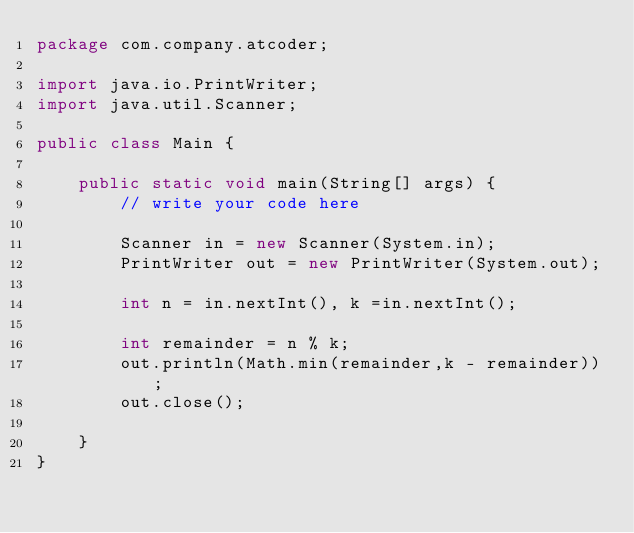Convert code to text. <code><loc_0><loc_0><loc_500><loc_500><_Java_>package com.company.atcoder;

import java.io.PrintWriter;
import java.util.Scanner;

public class Main {

    public static void main(String[] args) {
        // write your code here

        Scanner in = new Scanner(System.in);
        PrintWriter out = new PrintWriter(System.out);

        int n = in.nextInt(), k =in.nextInt();

        int remainder = n % k;
        out.println(Math.min(remainder,k - remainder));
        out.close();

    }
}
</code> 